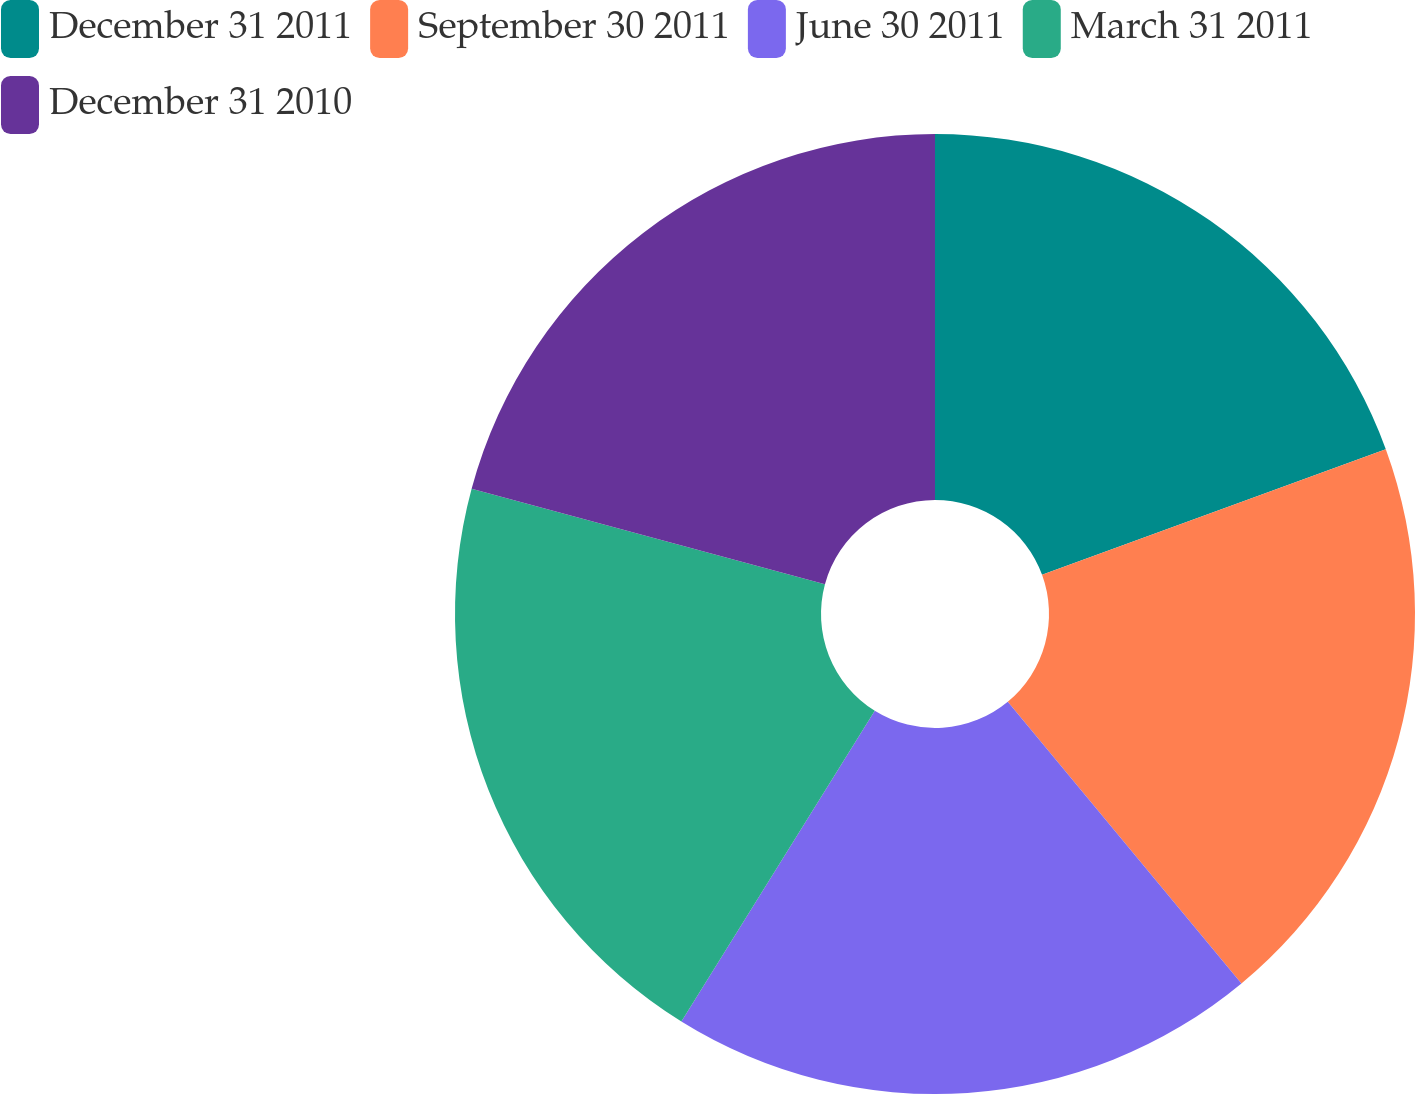<chart> <loc_0><loc_0><loc_500><loc_500><pie_chart><fcel>December 31 2011<fcel>September 30 2011<fcel>June 30 2011<fcel>March 31 2011<fcel>December 31 2010<nl><fcel>19.42%<fcel>19.56%<fcel>19.88%<fcel>20.34%<fcel>20.8%<nl></chart> 